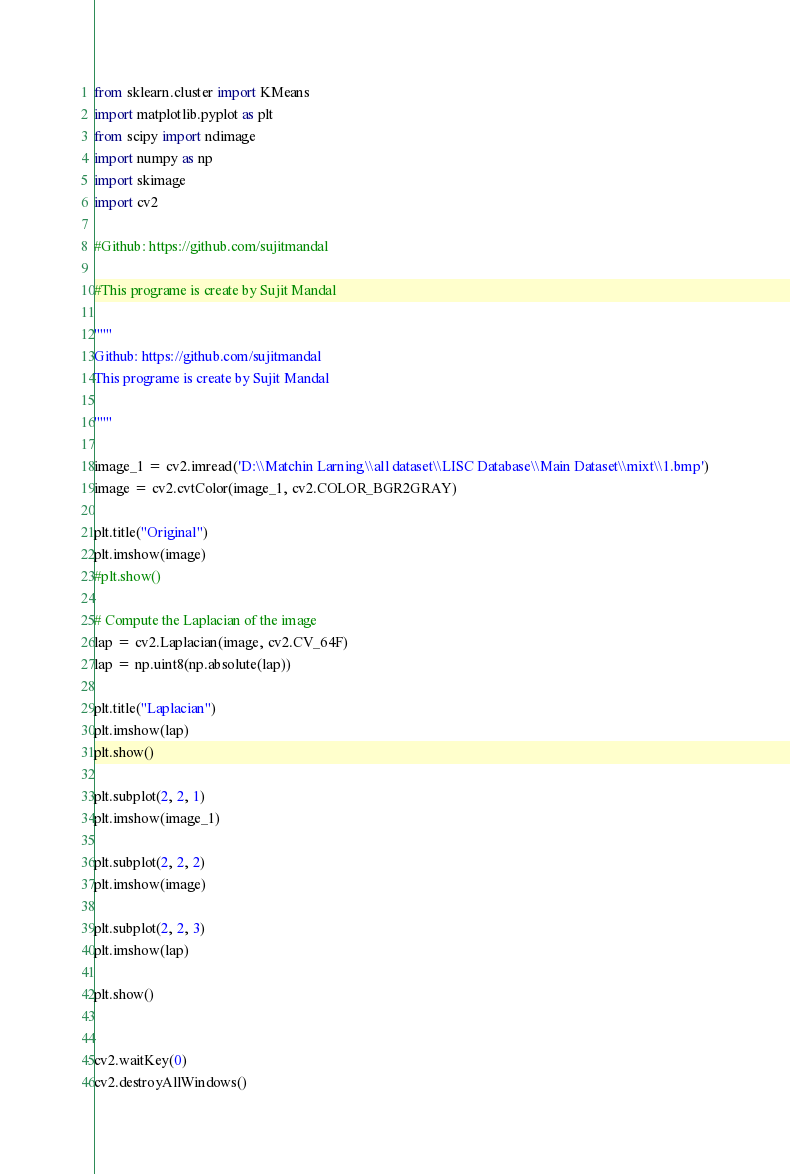Convert code to text. <code><loc_0><loc_0><loc_500><loc_500><_Python_>from sklearn.cluster import KMeans
import matplotlib.pyplot as plt
from scipy import ndimage
import numpy as np
import skimage
import cv2

#Github: https://github.com/sujitmandal

#This programe is create by Sujit Mandal

"""
Github: https://github.com/sujitmandal
This programe is create by Sujit Mandal

"""

image_1 = cv2.imread('D:\\Matchin Larning\\all dataset\\LISC Database\\Main Dataset\\mixt\\1.bmp')
image = cv2.cvtColor(image_1, cv2.COLOR_BGR2GRAY)

plt.title("Original")
plt.imshow(image)
#plt.show()

# Compute the Laplacian of the image
lap = cv2.Laplacian(image, cv2.CV_64F)
lap = np.uint8(np.absolute(lap))

plt.title("Laplacian")
plt.imshow(lap)
plt.show()

plt.subplot(2, 2, 1)
plt.imshow(image_1)

plt.subplot(2, 2, 2)
plt.imshow(image)

plt.subplot(2, 2, 3)
plt.imshow(lap)

plt.show()


cv2.waitKey(0)
cv2.destroyAllWindows()</code> 